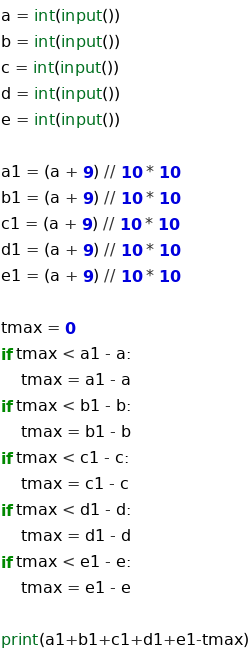<code> <loc_0><loc_0><loc_500><loc_500><_Python_>a = int(input())
b = int(input())
c = int(input())
d = int(input())
e = int(input())

a1 = (a + 9) // 10 * 10
b1 = (a + 9) // 10 * 10
c1 = (a + 9) // 10 * 10
d1 = (a + 9) // 10 * 10
e1 = (a + 9) // 10 * 10

tmax = 0
if tmax < a1 - a:
	tmax = a1 - a
if tmax < b1 - b:
	tmax = b1 - b
if tmax < c1 - c:
	tmax = c1 - c
if tmax < d1 - d:
	tmax = d1 - d
if tmax < e1 - e:
	tmax = e1 - e

print(a1+b1+c1+d1+e1-tmax)</code> 